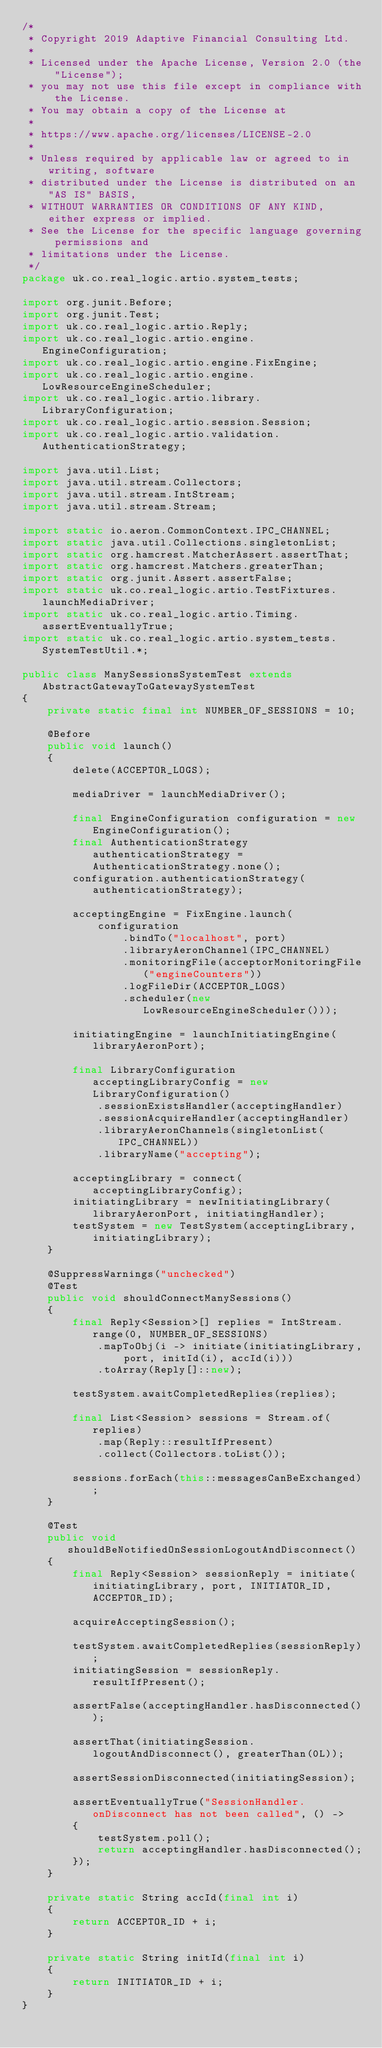<code> <loc_0><loc_0><loc_500><loc_500><_Java_>/*
 * Copyright 2019 Adaptive Financial Consulting Ltd.
 *
 * Licensed under the Apache License, Version 2.0 (the "License");
 * you may not use this file except in compliance with the License.
 * You may obtain a copy of the License at
 *
 * https://www.apache.org/licenses/LICENSE-2.0
 *
 * Unless required by applicable law or agreed to in writing, software
 * distributed under the License is distributed on an "AS IS" BASIS,
 * WITHOUT WARRANTIES OR CONDITIONS OF ANY KIND, either express or implied.
 * See the License for the specific language governing permissions and
 * limitations under the License.
 */
package uk.co.real_logic.artio.system_tests;

import org.junit.Before;
import org.junit.Test;
import uk.co.real_logic.artio.Reply;
import uk.co.real_logic.artio.engine.EngineConfiguration;
import uk.co.real_logic.artio.engine.FixEngine;
import uk.co.real_logic.artio.engine.LowResourceEngineScheduler;
import uk.co.real_logic.artio.library.LibraryConfiguration;
import uk.co.real_logic.artio.session.Session;
import uk.co.real_logic.artio.validation.AuthenticationStrategy;

import java.util.List;
import java.util.stream.Collectors;
import java.util.stream.IntStream;
import java.util.stream.Stream;

import static io.aeron.CommonContext.IPC_CHANNEL;
import static java.util.Collections.singletonList;
import static org.hamcrest.MatcherAssert.assertThat;
import static org.hamcrest.Matchers.greaterThan;
import static org.junit.Assert.assertFalse;
import static uk.co.real_logic.artio.TestFixtures.launchMediaDriver;
import static uk.co.real_logic.artio.Timing.assertEventuallyTrue;
import static uk.co.real_logic.artio.system_tests.SystemTestUtil.*;

public class ManySessionsSystemTest extends AbstractGatewayToGatewaySystemTest
{
    private static final int NUMBER_OF_SESSIONS = 10;

    @Before
    public void launch()
    {
        delete(ACCEPTOR_LOGS);

        mediaDriver = launchMediaDriver();

        final EngineConfiguration configuration = new EngineConfiguration();
        final AuthenticationStrategy authenticationStrategy = AuthenticationStrategy.none();
        configuration.authenticationStrategy(authenticationStrategy);

        acceptingEngine = FixEngine.launch(
            configuration
                .bindTo("localhost", port)
                .libraryAeronChannel(IPC_CHANNEL)
                .monitoringFile(acceptorMonitoringFile("engineCounters"))
                .logFileDir(ACCEPTOR_LOGS)
                .scheduler(new LowResourceEngineScheduler()));

        initiatingEngine = launchInitiatingEngine(libraryAeronPort);

        final LibraryConfiguration acceptingLibraryConfig = new LibraryConfiguration()
            .sessionExistsHandler(acceptingHandler)
            .sessionAcquireHandler(acceptingHandler)
            .libraryAeronChannels(singletonList(IPC_CHANNEL))
            .libraryName("accepting");

        acceptingLibrary = connect(acceptingLibraryConfig);
        initiatingLibrary = newInitiatingLibrary(libraryAeronPort, initiatingHandler);
        testSystem = new TestSystem(acceptingLibrary, initiatingLibrary);
    }

    @SuppressWarnings("unchecked")
    @Test
    public void shouldConnectManySessions()
    {
        final Reply<Session>[] replies = IntStream.range(0, NUMBER_OF_SESSIONS)
            .mapToObj(i -> initiate(initiatingLibrary, port, initId(i), accId(i)))
            .toArray(Reply[]::new);

        testSystem.awaitCompletedReplies(replies);

        final List<Session> sessions = Stream.of(replies)
            .map(Reply::resultIfPresent)
            .collect(Collectors.toList());

        sessions.forEach(this::messagesCanBeExchanged);
    }

    @Test
    public void shouldBeNotifiedOnSessionLogoutAndDisconnect()
    {
        final Reply<Session> sessionReply = initiate(initiatingLibrary, port, INITIATOR_ID, ACCEPTOR_ID);

        acquireAcceptingSession();

        testSystem.awaitCompletedReplies(sessionReply);
        initiatingSession = sessionReply.resultIfPresent();

        assertFalse(acceptingHandler.hasDisconnected());

        assertThat(initiatingSession.logoutAndDisconnect(), greaterThan(0L));

        assertSessionDisconnected(initiatingSession);

        assertEventuallyTrue("SessionHandler.onDisconnect has not been called", () ->
        {
            testSystem.poll();
            return acceptingHandler.hasDisconnected();
        });
    }

    private static String accId(final int i)
    {
        return ACCEPTOR_ID + i;
    }

    private static String initId(final int i)
    {
        return INITIATOR_ID + i;
    }
}
</code> 